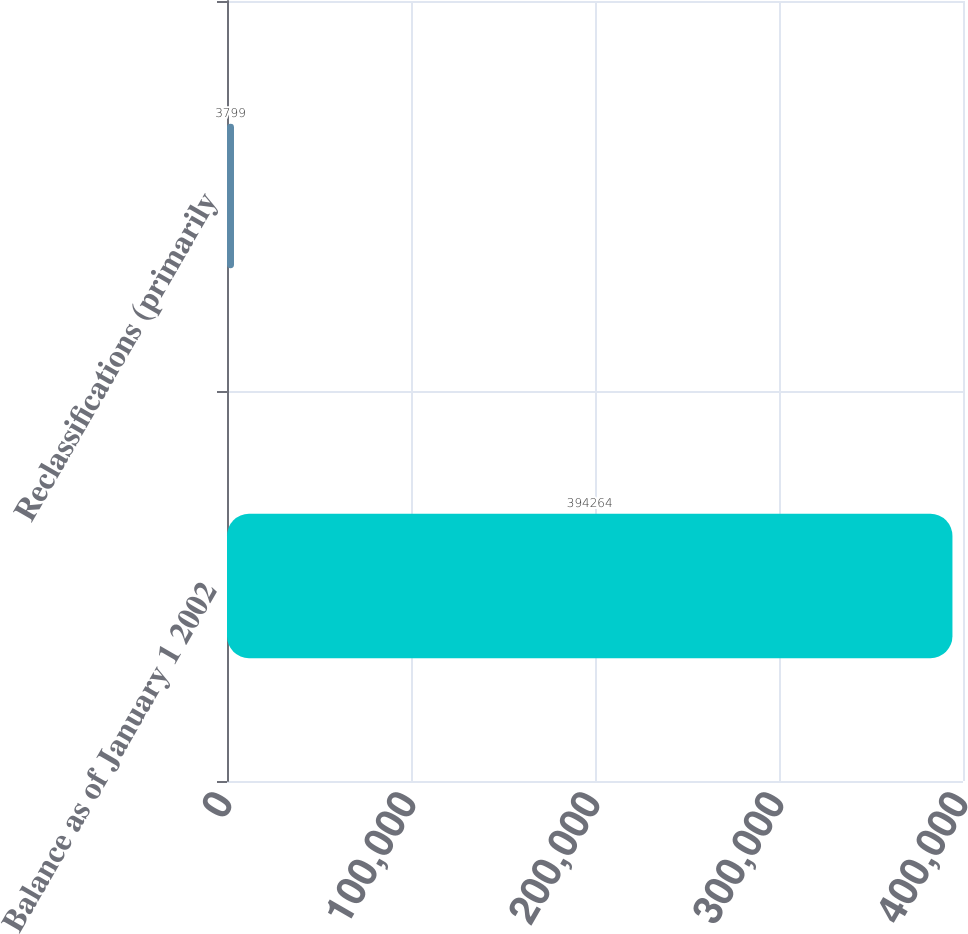<chart> <loc_0><loc_0><loc_500><loc_500><bar_chart><fcel>Balance as of January 1 2002<fcel>Reclassifications (primarily<nl><fcel>394264<fcel>3799<nl></chart> 